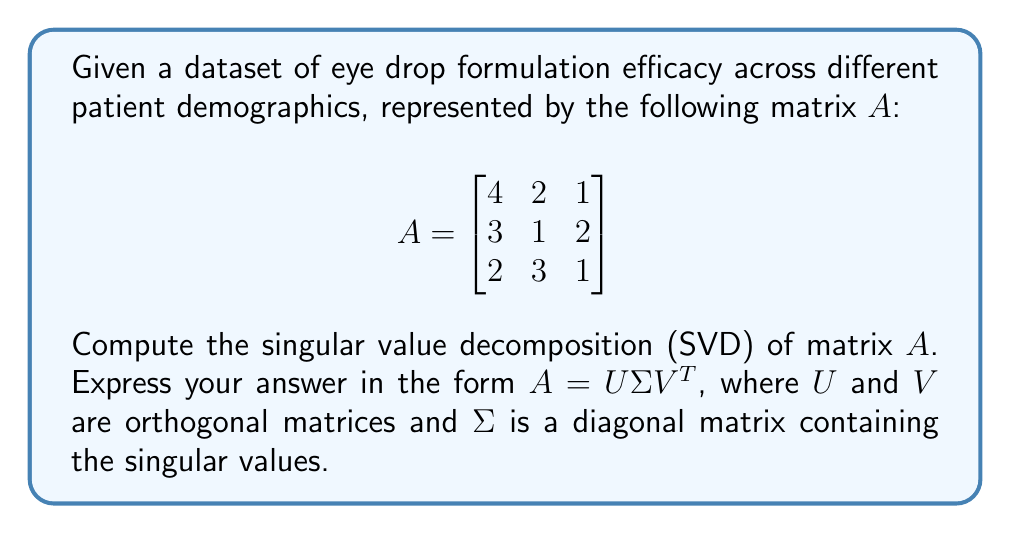Can you answer this question? To compute the singular value decomposition (SVD) of matrix $A$, we follow these steps:

1) First, calculate $A^TA$ and $AA^T$:

   $A^TA = \begin{bmatrix}
   4 & 3 & 2 \\
   2 & 1 & 3 \\
   1 & 2 & 1
   \end{bmatrix} \begin{bmatrix}
   4 & 2 & 1 \\
   3 & 1 & 2 \\
   2 & 3 & 1
   \end{bmatrix} = \begin{bmatrix}
   29 & 17 & 14 \\
   17 & 14 & 9 \\
   14 & 9 & 10
   \end{bmatrix}$

   $AA^T = \begin{bmatrix}
   4 & 2 & 1 \\
   3 & 1 & 2 \\
   2 & 3 & 1
   \end{bmatrix} \begin{bmatrix}
   4 & 3 & 2 \\
   2 & 1 & 3 \\
   1 & 2 & 1
   \end{bmatrix} = \begin{bmatrix}
   21 & 13 & 13 \\
   13 & 14 & 11 \\
   13 & 11 & 14
   \end{bmatrix}$

2) Find the eigenvalues of $A^TA$ (which are the squares of the singular values):
   
   $det(A^TA - \lambda I) = 0$
   
   Solving this characteristic equation gives us:
   $\lambda_1 \approx 45.722$, $\lambda_2 \approx 5.978$, $\lambda_3 \approx 1.300$

3) The singular values are the square roots of these eigenvalues:
   
   $\sigma_1 \approx 6.762$, $\sigma_2 \approx 2.445$, $\sigma_3 \approx 1.140$

4) Construct $\Sigma$:

   $\Sigma = \begin{bmatrix}
   6.762 & 0 & 0 \\
   0 & 2.445 & 0 \\
   0 & 0 & 1.140
   \end{bmatrix}$

5) Find the eigenvectors of $A^TA$ to form $V$:
   
   Solving $(A^TA - \lambda_i I)v_i = 0$ for each $\lambda_i$, we get:
   
   $V \approx \begin{bmatrix}
   0.745 & -0.570 & 0.346 \\
   0.507 & 0.676 & -0.535 \\
   0.434 & 0.467 & 0.771
   \end{bmatrix}$

6) Find the eigenvectors of $AA^T$ to form $U$:
   
   Solving $(AA^T - \lambda_i I)u_i = 0$ for each $\lambda_i$, we get:
   
   $U \approx \begin{bmatrix}
   0.679 & -0.722 & 0.132 \\
   0.526 & 0.384 & -0.759 \\
   0.513 & 0.576 & 0.637
   \end{bmatrix}$

Therefore, the singular value decomposition of $A$ is $A = U\Sigma V^T$.
Answer: $A = U\Sigma V^T$, where

$U \approx \begin{bmatrix}
0.679 & -0.722 & 0.132 \\
0.526 & 0.384 & -0.759 \\
0.513 & 0.576 & 0.637
\end{bmatrix}$

$\Sigma \approx \begin{bmatrix}
6.762 & 0 & 0 \\
0 & 2.445 & 0 \\
0 & 0 & 1.140
\end{bmatrix}$

$V^T \approx \begin{bmatrix}
0.745 & 0.507 & 0.434 \\
-0.570 & 0.676 & 0.467 \\
0.346 & -0.535 & 0.771
\end{bmatrix}$ 